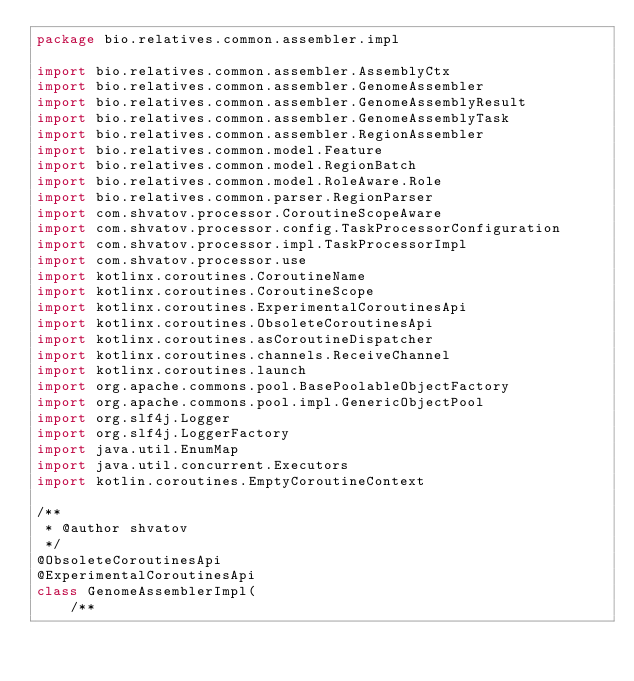Convert code to text. <code><loc_0><loc_0><loc_500><loc_500><_Kotlin_>package bio.relatives.common.assembler.impl

import bio.relatives.common.assembler.AssemblyCtx
import bio.relatives.common.assembler.GenomeAssembler
import bio.relatives.common.assembler.GenomeAssemblyResult
import bio.relatives.common.assembler.GenomeAssemblyTask
import bio.relatives.common.assembler.RegionAssembler
import bio.relatives.common.model.Feature
import bio.relatives.common.model.RegionBatch
import bio.relatives.common.model.RoleAware.Role
import bio.relatives.common.parser.RegionParser
import com.shvatov.processor.CoroutineScopeAware
import com.shvatov.processor.config.TaskProcessorConfiguration
import com.shvatov.processor.impl.TaskProcessorImpl
import com.shvatov.processor.use
import kotlinx.coroutines.CoroutineName
import kotlinx.coroutines.CoroutineScope
import kotlinx.coroutines.ExperimentalCoroutinesApi
import kotlinx.coroutines.ObsoleteCoroutinesApi
import kotlinx.coroutines.asCoroutineDispatcher
import kotlinx.coroutines.channels.ReceiveChannel
import kotlinx.coroutines.launch
import org.apache.commons.pool.BasePoolableObjectFactory
import org.apache.commons.pool.impl.GenericObjectPool
import org.slf4j.Logger
import org.slf4j.LoggerFactory
import java.util.EnumMap
import java.util.concurrent.Executors
import kotlin.coroutines.EmptyCoroutineContext

/**
 * @author shvatov
 */
@ObsoleteCoroutinesApi
@ExperimentalCoroutinesApi
class GenomeAssemblerImpl(
    /**</code> 